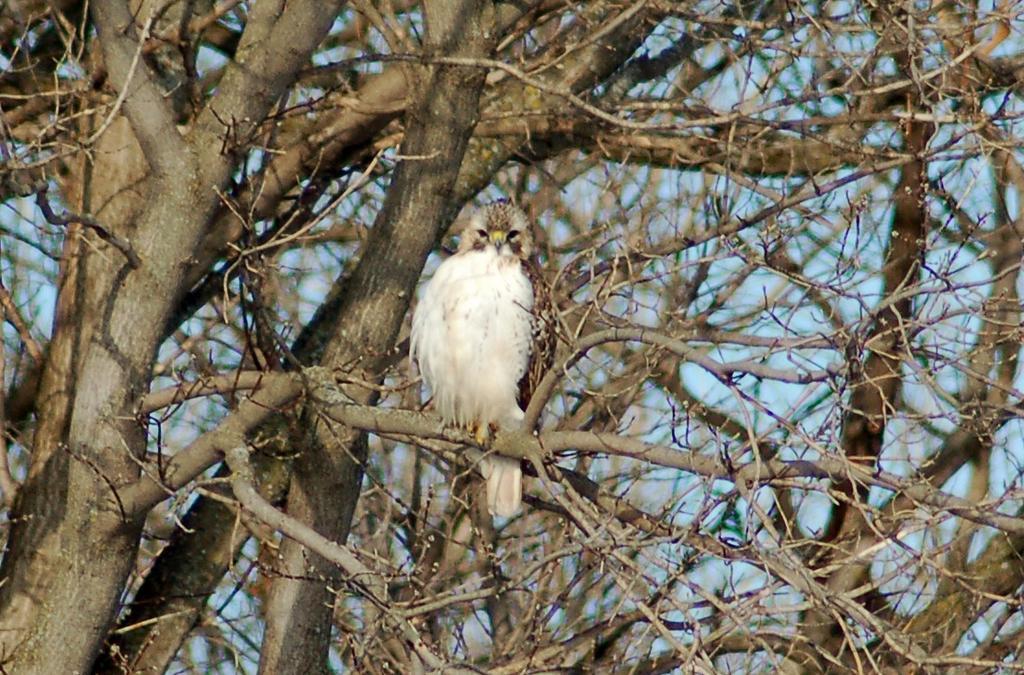Please provide a concise description of this image. In this image, I can see a bird on a branch. These are the trees with the branches and stems. 